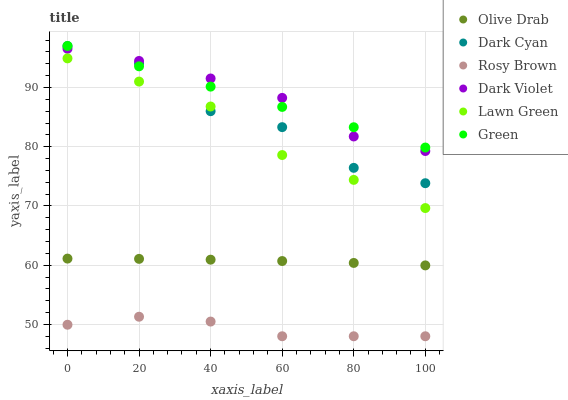Does Rosy Brown have the minimum area under the curve?
Answer yes or no. Yes. Does Dark Violet have the maximum area under the curve?
Answer yes or no. Yes. Does Dark Violet have the minimum area under the curve?
Answer yes or no. No. Does Rosy Brown have the maximum area under the curve?
Answer yes or no. No. Is Green the smoothest?
Answer yes or no. Yes. Is Dark Cyan the roughest?
Answer yes or no. Yes. Is Rosy Brown the smoothest?
Answer yes or no. No. Is Rosy Brown the roughest?
Answer yes or no. No. Does Rosy Brown have the lowest value?
Answer yes or no. Yes. Does Dark Violet have the lowest value?
Answer yes or no. No. Does Dark Cyan have the highest value?
Answer yes or no. Yes. Does Dark Violet have the highest value?
Answer yes or no. No. Is Olive Drab less than Green?
Answer yes or no. Yes. Is Dark Cyan greater than Rosy Brown?
Answer yes or no. Yes. Does Dark Violet intersect Dark Cyan?
Answer yes or no. Yes. Is Dark Violet less than Dark Cyan?
Answer yes or no. No. Is Dark Violet greater than Dark Cyan?
Answer yes or no. No. Does Olive Drab intersect Green?
Answer yes or no. No. 